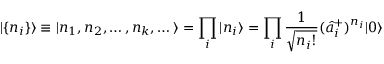Convert formula to latex. <formula><loc_0><loc_0><loc_500><loc_500>| \{ n _ { i } \} \rangle \equiv | n _ { 1 } , n _ { 2 } , \dots , n _ { k } , \dots \rangle = \prod _ { i } | n _ { i } \rangle = \prod _ { i } \frac { 1 } { \sqrt { n _ { i } ! } } ( \hat { a } _ { i } ^ { + } ) ^ { n _ { i } } | 0 \rangle</formula> 